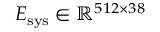<formula> <loc_0><loc_0><loc_500><loc_500>E _ { s y s } \in \mathbb { R } ^ { 5 1 2 \times 3 8 }</formula> 